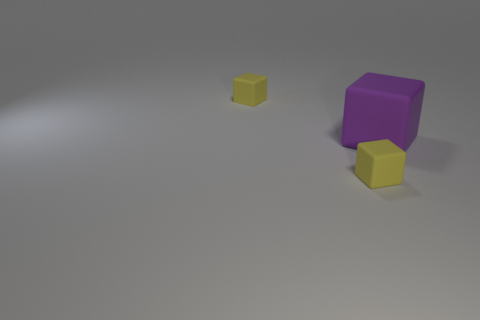Add 1 big brown rubber objects. How many objects exist? 4 Subtract all small rubber things. Subtract all big matte objects. How many objects are left? 0 Add 2 purple cubes. How many purple cubes are left? 3 Add 1 small cyan matte spheres. How many small cyan matte spheres exist? 1 Subtract 0 red balls. How many objects are left? 3 